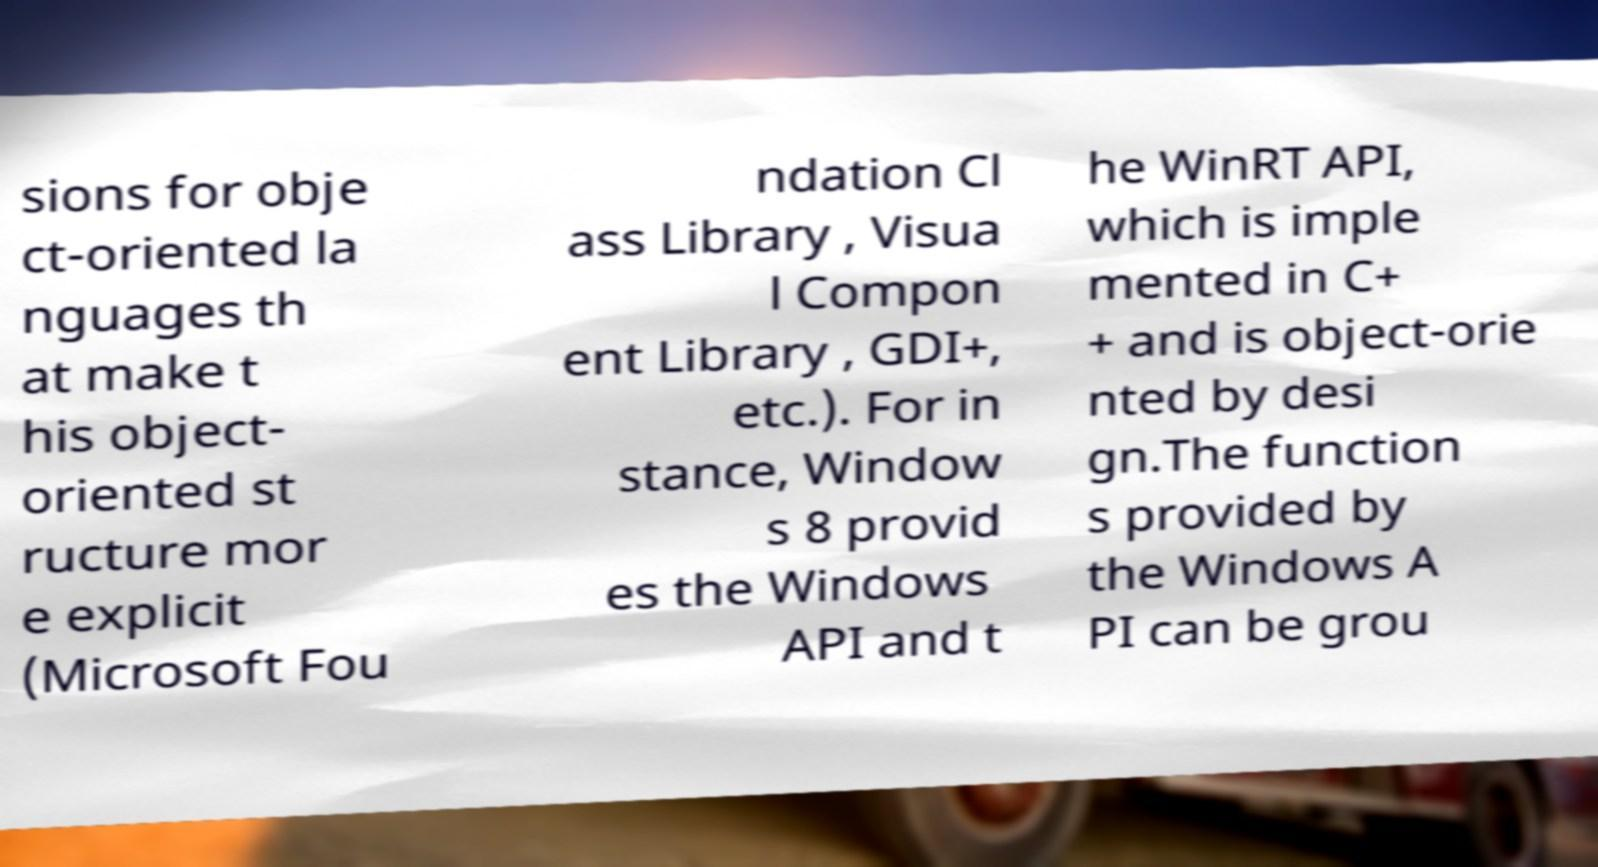I need the written content from this picture converted into text. Can you do that? sions for obje ct-oriented la nguages th at make t his object- oriented st ructure mor e explicit (Microsoft Fou ndation Cl ass Library , Visua l Compon ent Library , GDI+, etc.). For in stance, Window s 8 provid es the Windows API and t he WinRT API, which is imple mented in C+ + and is object-orie nted by desi gn.The function s provided by the Windows A PI can be grou 